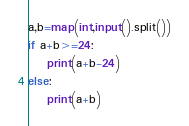<code> <loc_0><loc_0><loc_500><loc_500><_Python_>a,b=map(int,input().split())
if a+b>=24:
    print(a+b-24)
else:
    print(a+b)</code> 